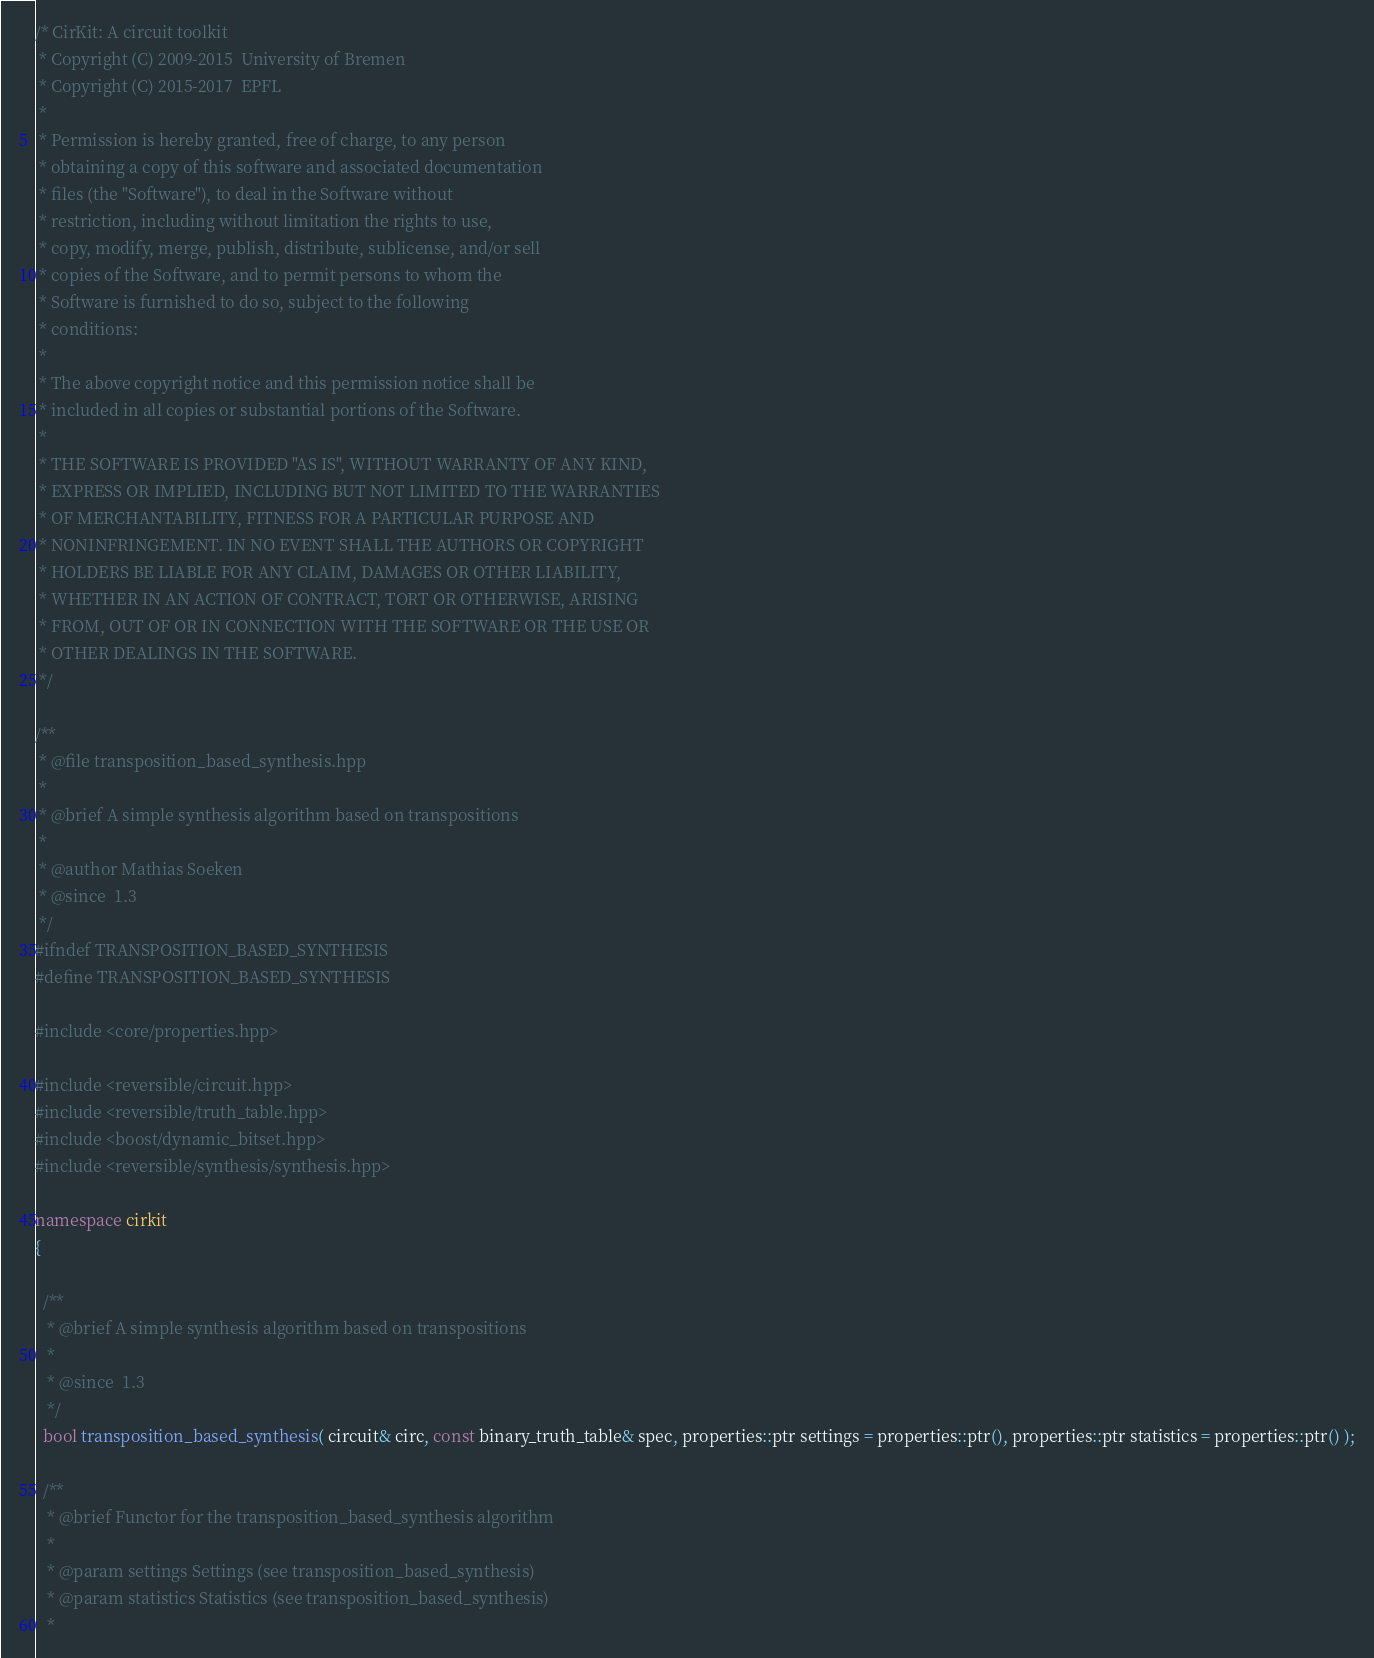<code> <loc_0><loc_0><loc_500><loc_500><_C++_>/* CirKit: A circuit toolkit
 * Copyright (C) 2009-2015  University of Bremen
 * Copyright (C) 2015-2017  EPFL
 *
 * Permission is hereby granted, free of charge, to any person
 * obtaining a copy of this software and associated documentation
 * files (the "Software"), to deal in the Software without
 * restriction, including without limitation the rights to use,
 * copy, modify, merge, publish, distribute, sublicense, and/or sell
 * copies of the Software, and to permit persons to whom the
 * Software is furnished to do so, subject to the following
 * conditions:
 *
 * The above copyright notice and this permission notice shall be
 * included in all copies or substantial portions of the Software.
 *
 * THE SOFTWARE IS PROVIDED "AS IS", WITHOUT WARRANTY OF ANY KIND,
 * EXPRESS OR IMPLIED, INCLUDING BUT NOT LIMITED TO THE WARRANTIES
 * OF MERCHANTABILITY, FITNESS FOR A PARTICULAR PURPOSE AND
 * NONINFRINGEMENT. IN NO EVENT SHALL THE AUTHORS OR COPYRIGHT
 * HOLDERS BE LIABLE FOR ANY CLAIM, DAMAGES OR OTHER LIABILITY,
 * WHETHER IN AN ACTION OF CONTRACT, TORT OR OTHERWISE, ARISING
 * FROM, OUT OF OR IN CONNECTION WITH THE SOFTWARE OR THE USE OR
 * OTHER DEALINGS IN THE SOFTWARE.
 */

/**
 * @file transposition_based_synthesis.hpp
 *
 * @brief A simple synthesis algorithm based on transpositions
 *
 * @author Mathias Soeken
 * @since  1.3
 */
#ifndef TRANSPOSITION_BASED_SYNTHESIS
#define TRANSPOSITION_BASED_SYNTHESIS

#include <core/properties.hpp>

#include <reversible/circuit.hpp>
#include <reversible/truth_table.hpp>
#include <boost/dynamic_bitset.hpp>
#include <reversible/synthesis/synthesis.hpp>

namespace cirkit
{

  /**
   * @brief A simple synthesis algorithm based on transpositions
   *
   * @since  1.3
   */
  bool transposition_based_synthesis( circuit& circ, const binary_truth_table& spec, properties::ptr settings = properties::ptr(), properties::ptr statistics = properties::ptr() );

  /**
   * @brief Functor for the transposition_based_synthesis algorithm
   *
   * @param settings Settings (see transposition_based_synthesis)
   * @param statistics Statistics (see transposition_based_synthesis)
   *</code> 